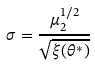<formula> <loc_0><loc_0><loc_500><loc_500>\sigma = \frac { \mu _ { 2 } ^ { 1 / 2 } } { \sqrt { \xi ( \theta ^ { * } ) } }</formula> 